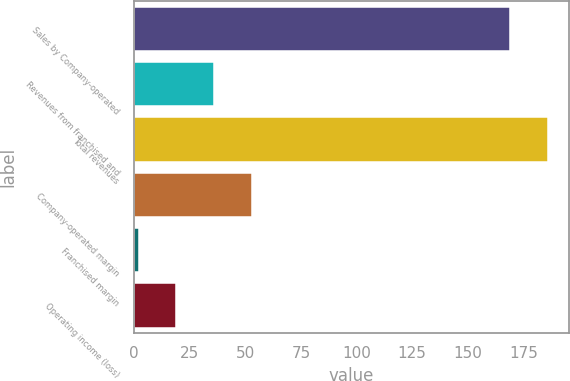Convert chart to OTSL. <chart><loc_0><loc_0><loc_500><loc_500><bar_chart><fcel>Sales by Company-operated<fcel>Revenues from franchised and<fcel>Total revenues<fcel>Company-operated margin<fcel>Franchised margin<fcel>Operating income (loss)<nl><fcel>169.1<fcel>36<fcel>186.05<fcel>52.95<fcel>2.1<fcel>19.05<nl></chart> 